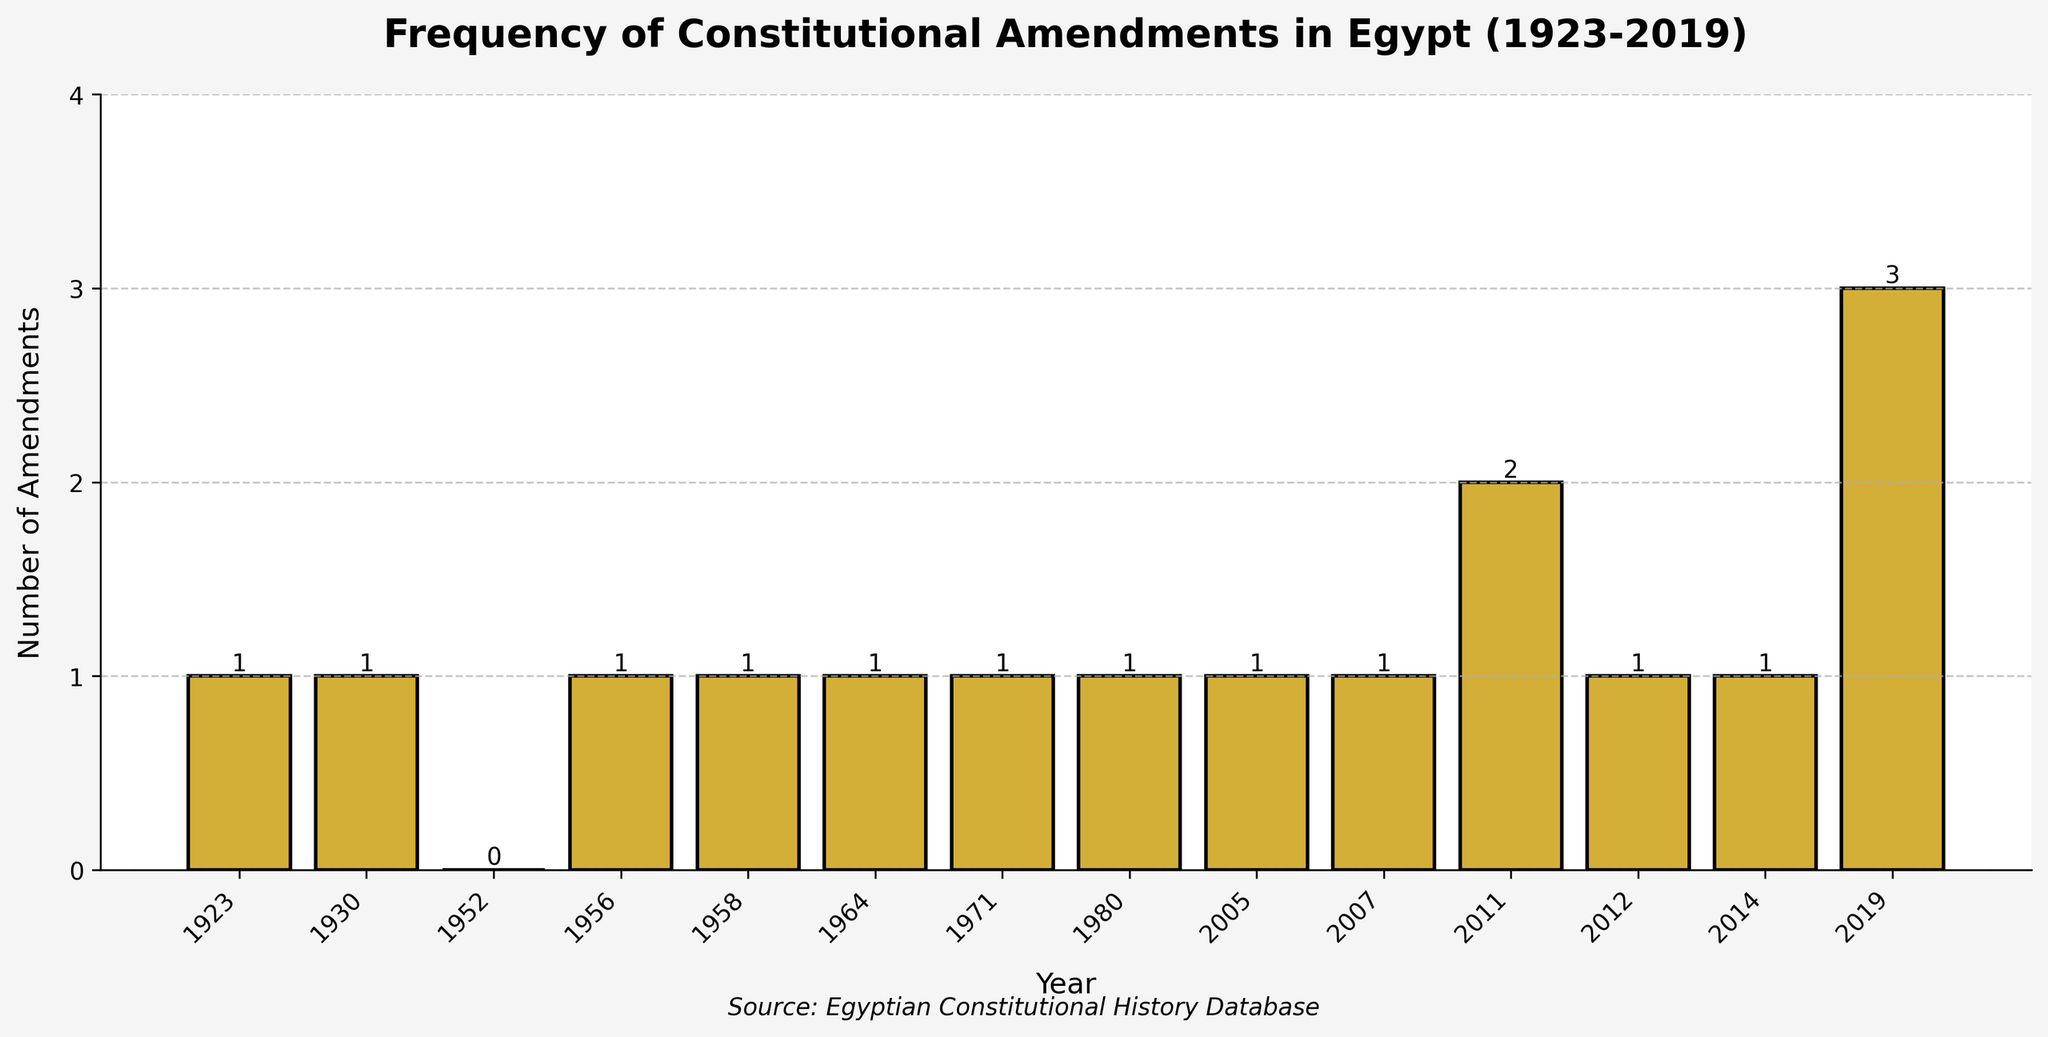What is the total number of constitutional amendments between 1923 and 2019? To find the total number of constitutional amendments, sum all the values from each year: 1 + 1 + 0 + 1 + 1 + 1 + 1 + 1 + 1 + 1 + 2 + 1 + 1 + 3 = 16
Answer: 16 Which year had the highest number of constitutional amendments? Looking at the heights of the bars, the year with the highest bar has the most amendments. The tallest bar corresponds to the year 2019 with 3 amendments.
Answer: 2019 What is the difference in the number of amendments between the years 1980 and 2019? Identify the heights of the bars for 1980 and 2019, which are 1 and 3 respectively. Calculate the difference: 3 - 1 = 2
Answer: 2 How many years had no constitutional amendments? Identify the bars with a height of 0. The year 1952 had no amendments, so the count is 1.
Answer: 1 What is the average number of constitutional amendments per year from 2010 to 2019? First, identify the number of amendments in each year: 2010 (0), 2011 (2), 2012 (1), 2013 (0), 2014 (1), 2015 (0), 2016 (0), 2017 (0), 2018 (0), 2019 (3). Sum them up: 0 + 2 + 1 + 0 + 1 + 0 + 0 + 0 + 0 + 3 = 7. There are 10 years, so the average is 7 / 10 = 0.7
Answer: 0.7 Which two consecutive years had the same number of constitutional amendments? Compare the heights of bars for all consecutive years. The heights for the years 1930 and 1956 both had 1 amendment each. Thus, 1930 and 1956.
Answer: 1930 and 1956 How does the number of amendments in 1958 compare to 1964? Identify the heights of the bars for the years 1958 and 1964. Both bars have the same height of 1.
Answer: They are equal Was there a period between 1971 and 2019 when Egypt had consecutive years with amendments? If so, which years? Check each year from 1971 to 2019 for consecutive years with amendments. The period from 2005 to 2007 had amendments in every year: 2005 (1), 2006 (0), and 2007 (1).
Answer: 2005 to 2007 What is the difference between the amendments in the year 2014 and the average amendments from 1923 to 1958? First, calculate the average amendments between 1923 and 1958: (1+1+0+1+1)/5 = 4/5 = 0.8. The amendments in 2014 are 1. The difference is 1 - 0.8 = 0.2
Answer: 0.2 How many years between 2000 and 2010 had constitutional amendments? Identify the years and count the bars with a height greater than 0: 2005 (1), 2007 (1), 2010 (0), giving a total of 2 years.
Answer: 2 